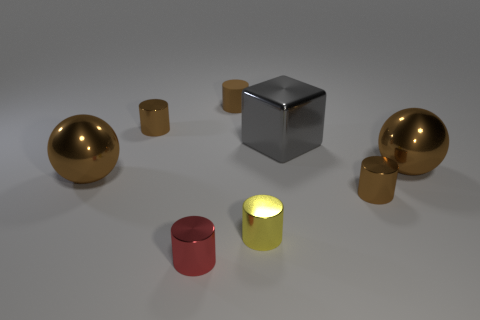Subtract all cyan spheres. How many brown cylinders are left? 3 Subtract all red cylinders. How many cylinders are left? 4 Subtract 2 cylinders. How many cylinders are left? 3 Subtract all yellow metal cylinders. How many cylinders are left? 4 Subtract all purple cylinders. Subtract all gray blocks. How many cylinders are left? 5 Add 1 small gray matte cylinders. How many objects exist? 9 Subtract all cubes. How many objects are left? 7 Subtract 0 gray spheres. How many objects are left? 8 Subtract all tiny red matte balls. Subtract all large brown objects. How many objects are left? 6 Add 7 red metal objects. How many red metal objects are left? 8 